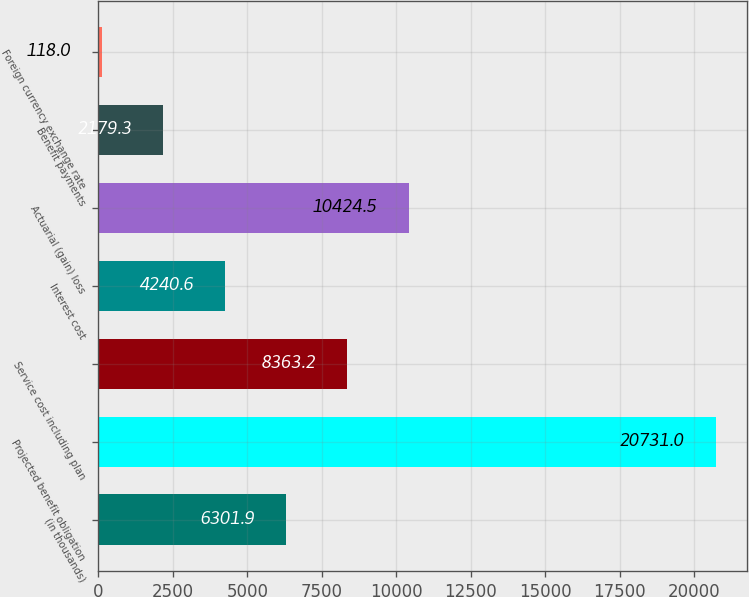<chart> <loc_0><loc_0><loc_500><loc_500><bar_chart><fcel>(in thousands)<fcel>Projected benefit obligation<fcel>Service cost including plan<fcel>Interest cost<fcel>Actuarial (gain) loss<fcel>Benefit payments<fcel>Foreign currency exchange rate<nl><fcel>6301.9<fcel>20731<fcel>8363.2<fcel>4240.6<fcel>10424.5<fcel>2179.3<fcel>118<nl></chart> 